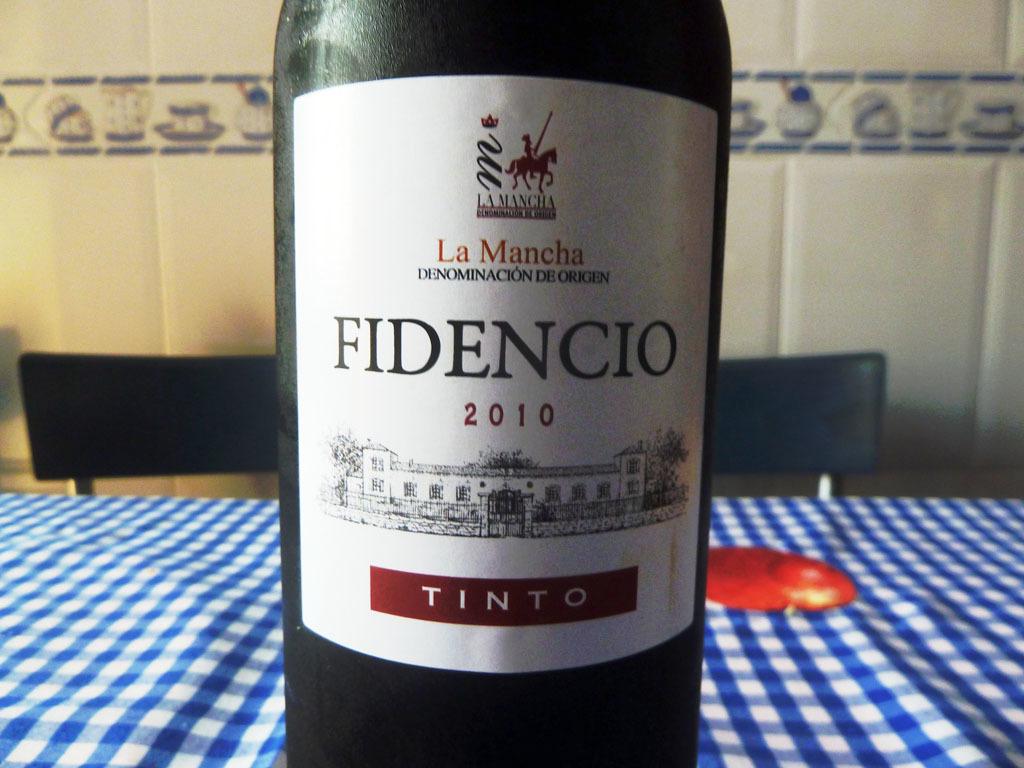In what year was this wine made?
Ensure brevity in your answer.  2010. What is the name of the wine?
Provide a succinct answer. Fidencio. 